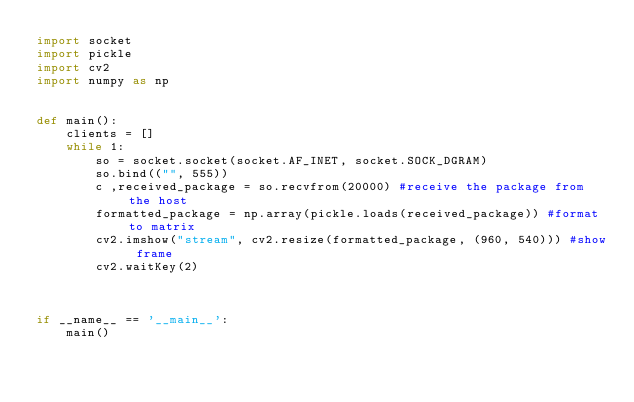<code> <loc_0><loc_0><loc_500><loc_500><_Python_>import socket
import pickle
import cv2
import numpy as np


def main():
    clients = []
    while 1:
        so = socket.socket(socket.AF_INET, socket.SOCK_DGRAM)
        so.bind(("", 555))
        c ,received_package = so.recvfrom(20000) #receive the package from the host
        formatted_package = np.array(pickle.loads(received_package)) #format to matrix
        cv2.imshow("stream", cv2.resize(formatted_package, (960, 540))) #show frame
        cv2.waitKey(2)



if __name__ == '__main__':
    main()</code> 